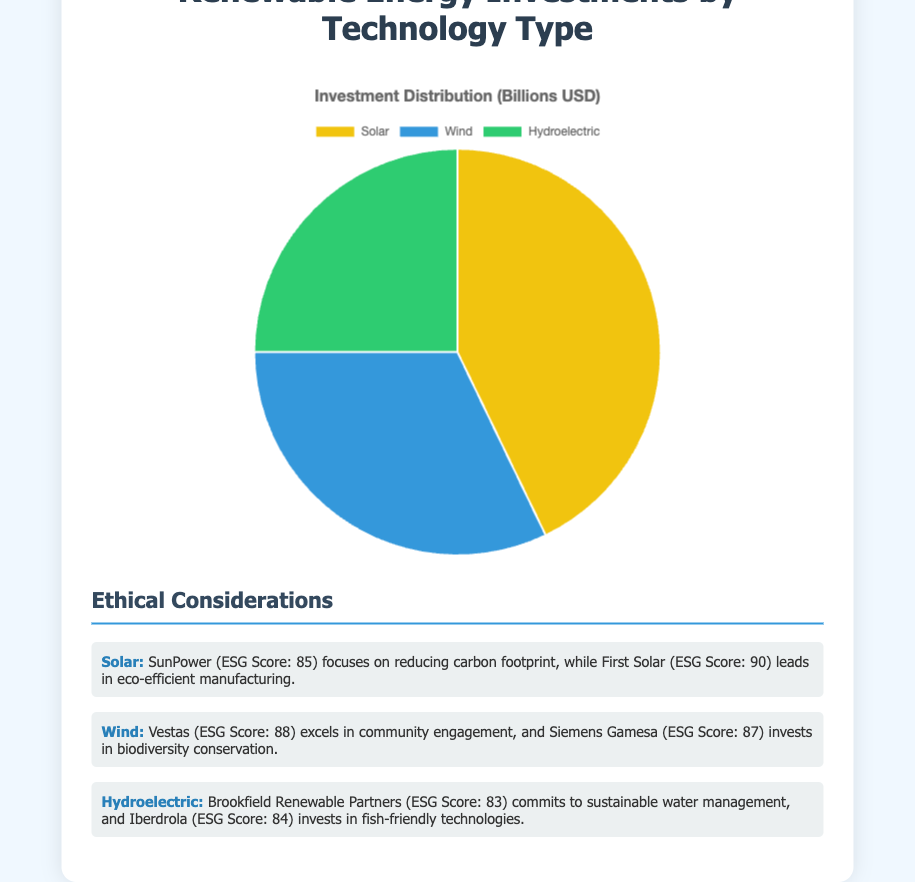What is the total investment amount across all technology types? Sum the amounts for Solar ($60B), Wind ($45B), and Hydroelectric ($35B). The total investment = 60 + 45 + 35 = $140B
Answer: $140 billion Which technology receives the highest investment? Look at the chart and compare the segments: Solar receives $60B, which is the largest among the three segments.
Answer: Solar How much more investment does Solar get compared to Hydroelectric? Calculate the difference between Solar ($60B) and Hydroelectric ($35B). Difference = 60 - 35 = $25B
Answer: $25 billion What is the average investment amount per technology type? Calculate the average by summing the investments (60 + 45 + 35 = $140B) and divide by 3. Average = 140 / 3 = $46.67B
Answer: $46.67 billion Which technology has the smallest investment? Look at the chart and determine the smallest segment; Hydroelectric receives $35B, the least of the three.
Answer: Hydroelectric What percentage of the total investment is allocated to Wind energy? Divide Wind investment ($45B) by the total investment ($140B) and multiply by 100. Percentage = (45 / 140) * 100 ≈ 32.14%
Answer: 32.14% By how much does the combined investment in Solar and Wind exceed the investment in Hydroelectric? Sum the investments in Solar ($60B) and Wind ($45B) and then subtract the Hydroelectric investment ($35B). Combined = 60 + 45 = $105B, Exceed by = 105 - 35 = $70B
Answer: $70 billion What are the ESG scores of entities involved in Solar technology investment? Refer to the ethical considerations: SunPower has an ESG score of 85 and First Solar has an ESG score of 90.
Answer: SunPower: 85, First Solar: 90 How much more investment is there in Wind energy compared to Hydroelectric energy? Calculate the difference: Wind ($45B) - Hydroelectric ($35B) = $10B
Answer: $10 billion What color represents Hydroelectric investments in the chart? Look at the chart colors and identify the one corresponding to the Hydroelectric segment. Hydroelectric is represented by green.
Answer: Green 